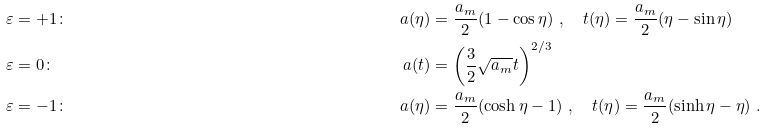<formula> <loc_0><loc_0><loc_500><loc_500>& \varepsilon = + 1 \colon & a ( \eta ) & = \frac { a _ { m } } { 2 } ( 1 - \cos \eta ) \ , \quad t ( \eta ) = \frac { a _ { m } } { 2 } ( \eta - \sin \eta ) \\ & \varepsilon = 0 \colon & a ( t ) & = \left ( \frac { 3 } { 2 } \sqrt { a _ { m } } t \right ) ^ { 2 / 3 } \\ & \varepsilon = - 1 \colon & a ( \eta ) & = \frac { a _ { m } } { 2 } ( \cosh \eta - 1 ) \ , \quad t ( \eta ) = \frac { a _ { m } } { 2 } ( \sinh \eta - \eta ) \ .</formula> 